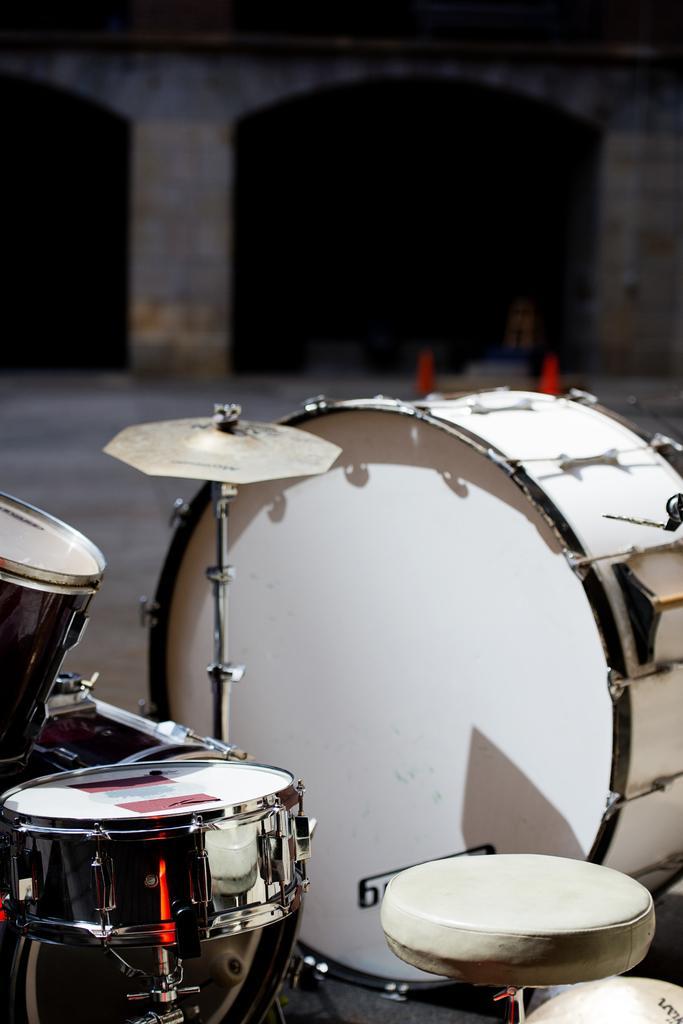Can you describe this image briefly? In the foreground of the image there are musical instruments. In the background of the image there is a building. There are safety poles. 